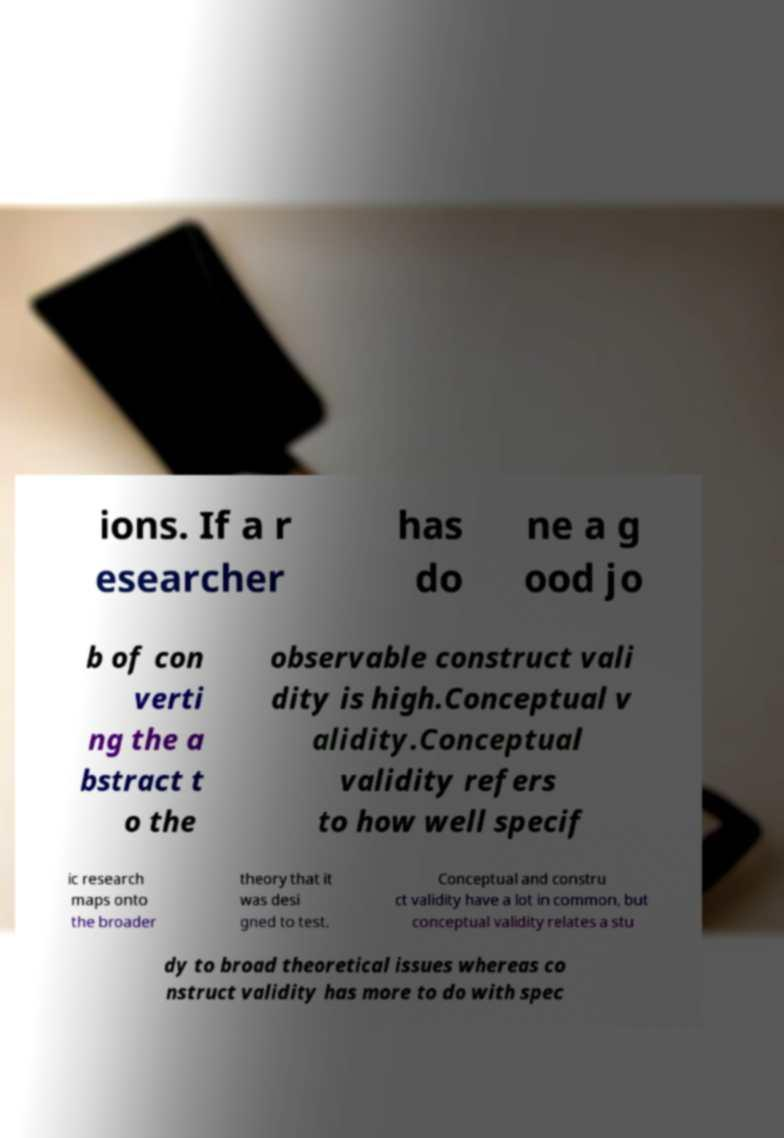What messages or text are displayed in this image? I need them in a readable, typed format. ions. If a r esearcher has do ne a g ood jo b of con verti ng the a bstract t o the observable construct vali dity is high.Conceptual v alidity.Conceptual validity refers to how well specif ic research maps onto the broader theory that it was desi gned to test. Conceptual and constru ct validity have a lot in common, but conceptual validity relates a stu dy to broad theoretical issues whereas co nstruct validity has more to do with spec 